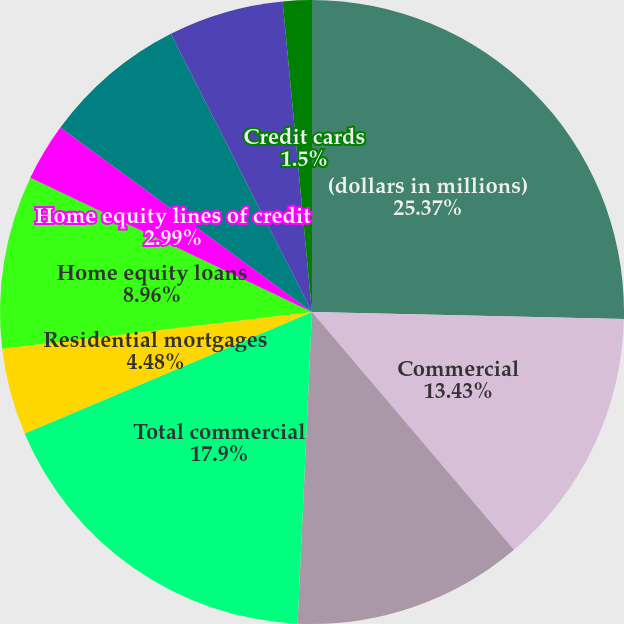Convert chart to OTSL. <chart><loc_0><loc_0><loc_500><loc_500><pie_chart><fcel>(dollars in millions)<fcel>Commercial<fcel>Commercial real estate<fcel>Total commercial<fcel>Residential mortgages<fcel>Home equity loans<fcel>Home equity lines of credit<fcel>Home equity loans serviced by<fcel>Automobile<fcel>Credit cards<nl><fcel>25.36%<fcel>13.43%<fcel>11.94%<fcel>17.9%<fcel>4.48%<fcel>8.96%<fcel>2.99%<fcel>7.46%<fcel>5.97%<fcel>1.5%<nl></chart> 